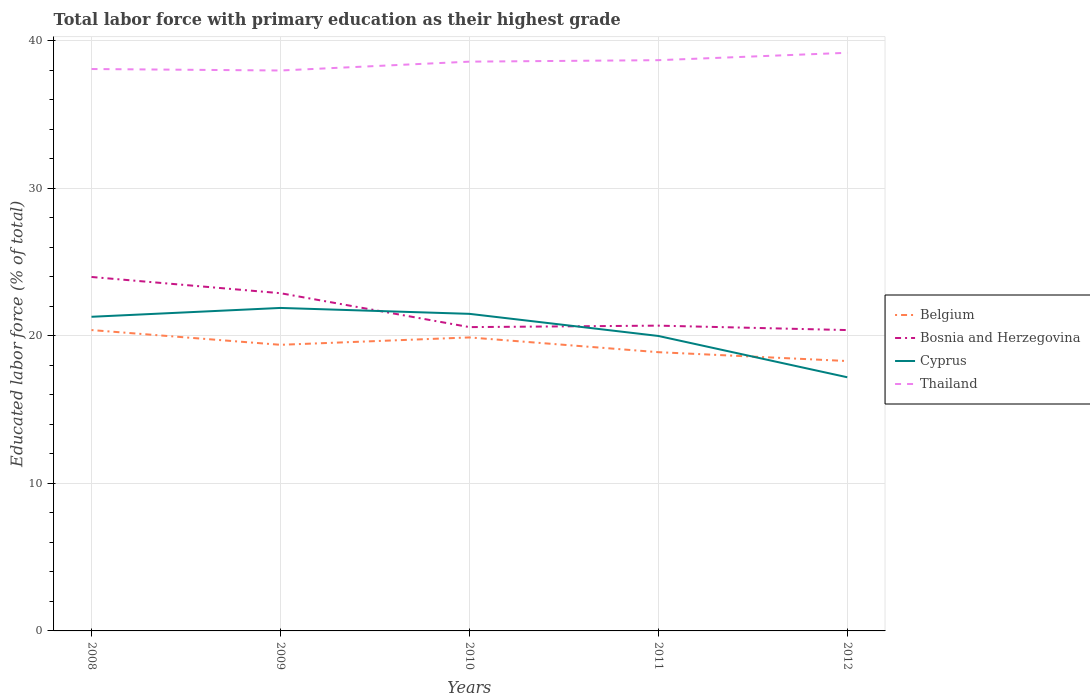Across all years, what is the maximum percentage of total labor force with primary education in Bosnia and Herzegovina?
Keep it short and to the point. 20.4. In which year was the percentage of total labor force with primary education in Thailand maximum?
Provide a succinct answer. 2009. What is the total percentage of total labor force with primary education in Bosnia and Herzegovina in the graph?
Make the answer very short. 1.1. What is the difference between the highest and the second highest percentage of total labor force with primary education in Belgium?
Provide a short and direct response. 2.1. Is the percentage of total labor force with primary education in Cyprus strictly greater than the percentage of total labor force with primary education in Belgium over the years?
Provide a succinct answer. No. How many lines are there?
Provide a succinct answer. 4. Does the graph contain grids?
Your answer should be compact. Yes. Where does the legend appear in the graph?
Provide a succinct answer. Center right. How many legend labels are there?
Your response must be concise. 4. How are the legend labels stacked?
Provide a short and direct response. Vertical. What is the title of the graph?
Offer a very short reply. Total labor force with primary education as their highest grade. What is the label or title of the Y-axis?
Your answer should be compact. Educated labor force (% of total). What is the Educated labor force (% of total) of Belgium in 2008?
Keep it short and to the point. 20.4. What is the Educated labor force (% of total) in Cyprus in 2008?
Keep it short and to the point. 21.3. What is the Educated labor force (% of total) of Thailand in 2008?
Your answer should be very brief. 38.1. What is the Educated labor force (% of total) of Belgium in 2009?
Your answer should be compact. 19.4. What is the Educated labor force (% of total) in Bosnia and Herzegovina in 2009?
Ensure brevity in your answer.  22.9. What is the Educated labor force (% of total) of Cyprus in 2009?
Ensure brevity in your answer.  21.9. What is the Educated labor force (% of total) of Belgium in 2010?
Ensure brevity in your answer.  19.9. What is the Educated labor force (% of total) in Bosnia and Herzegovina in 2010?
Make the answer very short. 20.6. What is the Educated labor force (% of total) in Cyprus in 2010?
Provide a short and direct response. 21.5. What is the Educated labor force (% of total) of Thailand in 2010?
Offer a very short reply. 38.6. What is the Educated labor force (% of total) of Belgium in 2011?
Offer a terse response. 18.9. What is the Educated labor force (% of total) in Bosnia and Herzegovina in 2011?
Ensure brevity in your answer.  20.7. What is the Educated labor force (% of total) of Thailand in 2011?
Offer a terse response. 38.7. What is the Educated labor force (% of total) of Belgium in 2012?
Offer a very short reply. 18.3. What is the Educated labor force (% of total) of Bosnia and Herzegovina in 2012?
Your answer should be compact. 20.4. What is the Educated labor force (% of total) of Cyprus in 2012?
Offer a very short reply. 17.2. What is the Educated labor force (% of total) of Thailand in 2012?
Your answer should be very brief. 39.2. Across all years, what is the maximum Educated labor force (% of total) of Belgium?
Offer a very short reply. 20.4. Across all years, what is the maximum Educated labor force (% of total) of Cyprus?
Keep it short and to the point. 21.9. Across all years, what is the maximum Educated labor force (% of total) in Thailand?
Provide a succinct answer. 39.2. Across all years, what is the minimum Educated labor force (% of total) of Belgium?
Offer a very short reply. 18.3. Across all years, what is the minimum Educated labor force (% of total) in Bosnia and Herzegovina?
Provide a succinct answer. 20.4. Across all years, what is the minimum Educated labor force (% of total) in Cyprus?
Give a very brief answer. 17.2. Across all years, what is the minimum Educated labor force (% of total) of Thailand?
Provide a short and direct response. 38. What is the total Educated labor force (% of total) in Belgium in the graph?
Provide a succinct answer. 96.9. What is the total Educated labor force (% of total) of Bosnia and Herzegovina in the graph?
Provide a succinct answer. 108.6. What is the total Educated labor force (% of total) in Cyprus in the graph?
Make the answer very short. 101.9. What is the total Educated labor force (% of total) in Thailand in the graph?
Keep it short and to the point. 192.6. What is the difference between the Educated labor force (% of total) in Belgium in 2008 and that in 2009?
Your answer should be compact. 1. What is the difference between the Educated labor force (% of total) of Cyprus in 2008 and that in 2009?
Your answer should be compact. -0.6. What is the difference between the Educated labor force (% of total) of Bosnia and Herzegovina in 2008 and that in 2011?
Provide a short and direct response. 3.3. What is the difference between the Educated labor force (% of total) in Cyprus in 2008 and that in 2011?
Offer a terse response. 1.3. What is the difference between the Educated labor force (% of total) in Thailand in 2008 and that in 2011?
Keep it short and to the point. -0.6. What is the difference between the Educated labor force (% of total) of Belgium in 2009 and that in 2010?
Ensure brevity in your answer.  -0.5. What is the difference between the Educated labor force (% of total) of Bosnia and Herzegovina in 2009 and that in 2010?
Make the answer very short. 2.3. What is the difference between the Educated labor force (% of total) of Thailand in 2009 and that in 2010?
Offer a very short reply. -0.6. What is the difference between the Educated labor force (% of total) of Belgium in 2009 and that in 2011?
Keep it short and to the point. 0.5. What is the difference between the Educated labor force (% of total) of Bosnia and Herzegovina in 2009 and that in 2011?
Offer a very short reply. 2.2. What is the difference between the Educated labor force (% of total) of Cyprus in 2009 and that in 2011?
Ensure brevity in your answer.  1.9. What is the difference between the Educated labor force (% of total) in Thailand in 2009 and that in 2011?
Provide a short and direct response. -0.7. What is the difference between the Educated labor force (% of total) in Belgium in 2009 and that in 2012?
Give a very brief answer. 1.1. What is the difference between the Educated labor force (% of total) in Belgium in 2010 and that in 2011?
Your answer should be very brief. 1. What is the difference between the Educated labor force (% of total) of Thailand in 2010 and that in 2011?
Offer a terse response. -0.1. What is the difference between the Educated labor force (% of total) of Belgium in 2010 and that in 2012?
Provide a short and direct response. 1.6. What is the difference between the Educated labor force (% of total) in Cyprus in 2010 and that in 2012?
Provide a short and direct response. 4.3. What is the difference between the Educated labor force (% of total) of Thailand in 2010 and that in 2012?
Give a very brief answer. -0.6. What is the difference between the Educated labor force (% of total) of Bosnia and Herzegovina in 2011 and that in 2012?
Offer a terse response. 0.3. What is the difference between the Educated labor force (% of total) of Cyprus in 2011 and that in 2012?
Your answer should be very brief. 2.8. What is the difference between the Educated labor force (% of total) in Belgium in 2008 and the Educated labor force (% of total) in Cyprus in 2009?
Offer a terse response. -1.5. What is the difference between the Educated labor force (% of total) in Belgium in 2008 and the Educated labor force (% of total) in Thailand in 2009?
Your answer should be very brief. -17.6. What is the difference between the Educated labor force (% of total) in Bosnia and Herzegovina in 2008 and the Educated labor force (% of total) in Cyprus in 2009?
Provide a succinct answer. 2.1. What is the difference between the Educated labor force (% of total) in Bosnia and Herzegovina in 2008 and the Educated labor force (% of total) in Thailand in 2009?
Make the answer very short. -14. What is the difference between the Educated labor force (% of total) of Cyprus in 2008 and the Educated labor force (% of total) of Thailand in 2009?
Your answer should be compact. -16.7. What is the difference between the Educated labor force (% of total) of Belgium in 2008 and the Educated labor force (% of total) of Bosnia and Herzegovina in 2010?
Your response must be concise. -0.2. What is the difference between the Educated labor force (% of total) of Belgium in 2008 and the Educated labor force (% of total) of Thailand in 2010?
Your answer should be compact. -18.2. What is the difference between the Educated labor force (% of total) of Bosnia and Herzegovina in 2008 and the Educated labor force (% of total) of Thailand in 2010?
Provide a succinct answer. -14.6. What is the difference between the Educated labor force (% of total) of Cyprus in 2008 and the Educated labor force (% of total) of Thailand in 2010?
Offer a terse response. -17.3. What is the difference between the Educated labor force (% of total) of Belgium in 2008 and the Educated labor force (% of total) of Bosnia and Herzegovina in 2011?
Offer a terse response. -0.3. What is the difference between the Educated labor force (% of total) in Belgium in 2008 and the Educated labor force (% of total) in Thailand in 2011?
Offer a terse response. -18.3. What is the difference between the Educated labor force (% of total) in Bosnia and Herzegovina in 2008 and the Educated labor force (% of total) in Cyprus in 2011?
Give a very brief answer. 4. What is the difference between the Educated labor force (% of total) of Bosnia and Herzegovina in 2008 and the Educated labor force (% of total) of Thailand in 2011?
Give a very brief answer. -14.7. What is the difference between the Educated labor force (% of total) in Cyprus in 2008 and the Educated labor force (% of total) in Thailand in 2011?
Give a very brief answer. -17.4. What is the difference between the Educated labor force (% of total) in Belgium in 2008 and the Educated labor force (% of total) in Bosnia and Herzegovina in 2012?
Offer a very short reply. 0. What is the difference between the Educated labor force (% of total) in Belgium in 2008 and the Educated labor force (% of total) in Thailand in 2012?
Your answer should be very brief. -18.8. What is the difference between the Educated labor force (% of total) in Bosnia and Herzegovina in 2008 and the Educated labor force (% of total) in Cyprus in 2012?
Keep it short and to the point. 6.8. What is the difference between the Educated labor force (% of total) in Bosnia and Herzegovina in 2008 and the Educated labor force (% of total) in Thailand in 2012?
Give a very brief answer. -15.2. What is the difference between the Educated labor force (% of total) of Cyprus in 2008 and the Educated labor force (% of total) of Thailand in 2012?
Offer a terse response. -17.9. What is the difference between the Educated labor force (% of total) in Belgium in 2009 and the Educated labor force (% of total) in Cyprus in 2010?
Your response must be concise. -2.1. What is the difference between the Educated labor force (% of total) in Belgium in 2009 and the Educated labor force (% of total) in Thailand in 2010?
Provide a succinct answer. -19.2. What is the difference between the Educated labor force (% of total) in Bosnia and Herzegovina in 2009 and the Educated labor force (% of total) in Cyprus in 2010?
Give a very brief answer. 1.4. What is the difference between the Educated labor force (% of total) of Bosnia and Herzegovina in 2009 and the Educated labor force (% of total) of Thailand in 2010?
Offer a very short reply. -15.7. What is the difference between the Educated labor force (% of total) of Cyprus in 2009 and the Educated labor force (% of total) of Thailand in 2010?
Provide a short and direct response. -16.7. What is the difference between the Educated labor force (% of total) of Belgium in 2009 and the Educated labor force (% of total) of Cyprus in 2011?
Offer a terse response. -0.6. What is the difference between the Educated labor force (% of total) of Belgium in 2009 and the Educated labor force (% of total) of Thailand in 2011?
Make the answer very short. -19.3. What is the difference between the Educated labor force (% of total) of Bosnia and Herzegovina in 2009 and the Educated labor force (% of total) of Thailand in 2011?
Give a very brief answer. -15.8. What is the difference between the Educated labor force (% of total) in Cyprus in 2009 and the Educated labor force (% of total) in Thailand in 2011?
Keep it short and to the point. -16.8. What is the difference between the Educated labor force (% of total) of Belgium in 2009 and the Educated labor force (% of total) of Bosnia and Herzegovina in 2012?
Give a very brief answer. -1. What is the difference between the Educated labor force (% of total) of Belgium in 2009 and the Educated labor force (% of total) of Cyprus in 2012?
Your answer should be very brief. 2.2. What is the difference between the Educated labor force (% of total) of Belgium in 2009 and the Educated labor force (% of total) of Thailand in 2012?
Your answer should be compact. -19.8. What is the difference between the Educated labor force (% of total) in Bosnia and Herzegovina in 2009 and the Educated labor force (% of total) in Thailand in 2012?
Keep it short and to the point. -16.3. What is the difference between the Educated labor force (% of total) of Cyprus in 2009 and the Educated labor force (% of total) of Thailand in 2012?
Offer a terse response. -17.3. What is the difference between the Educated labor force (% of total) of Belgium in 2010 and the Educated labor force (% of total) of Thailand in 2011?
Make the answer very short. -18.8. What is the difference between the Educated labor force (% of total) in Bosnia and Herzegovina in 2010 and the Educated labor force (% of total) in Cyprus in 2011?
Provide a short and direct response. 0.6. What is the difference between the Educated labor force (% of total) in Bosnia and Herzegovina in 2010 and the Educated labor force (% of total) in Thailand in 2011?
Offer a very short reply. -18.1. What is the difference between the Educated labor force (% of total) of Cyprus in 2010 and the Educated labor force (% of total) of Thailand in 2011?
Your answer should be compact. -17.2. What is the difference between the Educated labor force (% of total) in Belgium in 2010 and the Educated labor force (% of total) in Cyprus in 2012?
Provide a short and direct response. 2.7. What is the difference between the Educated labor force (% of total) of Belgium in 2010 and the Educated labor force (% of total) of Thailand in 2012?
Keep it short and to the point. -19.3. What is the difference between the Educated labor force (% of total) in Bosnia and Herzegovina in 2010 and the Educated labor force (% of total) in Thailand in 2012?
Your response must be concise. -18.6. What is the difference between the Educated labor force (% of total) in Cyprus in 2010 and the Educated labor force (% of total) in Thailand in 2012?
Your response must be concise. -17.7. What is the difference between the Educated labor force (% of total) of Belgium in 2011 and the Educated labor force (% of total) of Thailand in 2012?
Provide a succinct answer. -20.3. What is the difference between the Educated labor force (% of total) of Bosnia and Herzegovina in 2011 and the Educated labor force (% of total) of Cyprus in 2012?
Provide a short and direct response. 3.5. What is the difference between the Educated labor force (% of total) in Bosnia and Herzegovina in 2011 and the Educated labor force (% of total) in Thailand in 2012?
Ensure brevity in your answer.  -18.5. What is the difference between the Educated labor force (% of total) of Cyprus in 2011 and the Educated labor force (% of total) of Thailand in 2012?
Your answer should be compact. -19.2. What is the average Educated labor force (% of total) of Belgium per year?
Provide a short and direct response. 19.38. What is the average Educated labor force (% of total) of Bosnia and Herzegovina per year?
Your answer should be very brief. 21.72. What is the average Educated labor force (% of total) in Cyprus per year?
Ensure brevity in your answer.  20.38. What is the average Educated labor force (% of total) of Thailand per year?
Make the answer very short. 38.52. In the year 2008, what is the difference between the Educated labor force (% of total) of Belgium and Educated labor force (% of total) of Bosnia and Herzegovina?
Offer a terse response. -3.6. In the year 2008, what is the difference between the Educated labor force (% of total) of Belgium and Educated labor force (% of total) of Cyprus?
Provide a succinct answer. -0.9. In the year 2008, what is the difference between the Educated labor force (% of total) of Belgium and Educated labor force (% of total) of Thailand?
Offer a very short reply. -17.7. In the year 2008, what is the difference between the Educated labor force (% of total) of Bosnia and Herzegovina and Educated labor force (% of total) of Cyprus?
Your answer should be compact. 2.7. In the year 2008, what is the difference between the Educated labor force (% of total) of Bosnia and Herzegovina and Educated labor force (% of total) of Thailand?
Your answer should be very brief. -14.1. In the year 2008, what is the difference between the Educated labor force (% of total) of Cyprus and Educated labor force (% of total) of Thailand?
Provide a short and direct response. -16.8. In the year 2009, what is the difference between the Educated labor force (% of total) in Belgium and Educated labor force (% of total) in Bosnia and Herzegovina?
Offer a very short reply. -3.5. In the year 2009, what is the difference between the Educated labor force (% of total) in Belgium and Educated labor force (% of total) in Cyprus?
Make the answer very short. -2.5. In the year 2009, what is the difference between the Educated labor force (% of total) in Belgium and Educated labor force (% of total) in Thailand?
Provide a short and direct response. -18.6. In the year 2009, what is the difference between the Educated labor force (% of total) in Bosnia and Herzegovina and Educated labor force (% of total) in Thailand?
Give a very brief answer. -15.1. In the year 2009, what is the difference between the Educated labor force (% of total) in Cyprus and Educated labor force (% of total) in Thailand?
Your answer should be compact. -16.1. In the year 2010, what is the difference between the Educated labor force (% of total) of Belgium and Educated labor force (% of total) of Thailand?
Your answer should be compact. -18.7. In the year 2010, what is the difference between the Educated labor force (% of total) of Cyprus and Educated labor force (% of total) of Thailand?
Make the answer very short. -17.1. In the year 2011, what is the difference between the Educated labor force (% of total) of Belgium and Educated labor force (% of total) of Thailand?
Your response must be concise. -19.8. In the year 2011, what is the difference between the Educated labor force (% of total) in Cyprus and Educated labor force (% of total) in Thailand?
Keep it short and to the point. -18.7. In the year 2012, what is the difference between the Educated labor force (% of total) of Belgium and Educated labor force (% of total) of Thailand?
Offer a very short reply. -20.9. In the year 2012, what is the difference between the Educated labor force (% of total) in Bosnia and Herzegovina and Educated labor force (% of total) in Thailand?
Give a very brief answer. -18.8. In the year 2012, what is the difference between the Educated labor force (% of total) in Cyprus and Educated labor force (% of total) in Thailand?
Ensure brevity in your answer.  -22. What is the ratio of the Educated labor force (% of total) in Belgium in 2008 to that in 2009?
Provide a succinct answer. 1.05. What is the ratio of the Educated labor force (% of total) of Bosnia and Herzegovina in 2008 to that in 2009?
Give a very brief answer. 1.05. What is the ratio of the Educated labor force (% of total) in Cyprus in 2008 to that in 2009?
Give a very brief answer. 0.97. What is the ratio of the Educated labor force (% of total) in Thailand in 2008 to that in 2009?
Provide a short and direct response. 1. What is the ratio of the Educated labor force (% of total) of Belgium in 2008 to that in 2010?
Your response must be concise. 1.03. What is the ratio of the Educated labor force (% of total) of Bosnia and Herzegovina in 2008 to that in 2010?
Offer a terse response. 1.17. What is the ratio of the Educated labor force (% of total) in Belgium in 2008 to that in 2011?
Offer a very short reply. 1.08. What is the ratio of the Educated labor force (% of total) of Bosnia and Herzegovina in 2008 to that in 2011?
Keep it short and to the point. 1.16. What is the ratio of the Educated labor force (% of total) in Cyprus in 2008 to that in 2011?
Give a very brief answer. 1.06. What is the ratio of the Educated labor force (% of total) of Thailand in 2008 to that in 2011?
Keep it short and to the point. 0.98. What is the ratio of the Educated labor force (% of total) in Belgium in 2008 to that in 2012?
Your response must be concise. 1.11. What is the ratio of the Educated labor force (% of total) of Bosnia and Herzegovina in 2008 to that in 2012?
Your answer should be very brief. 1.18. What is the ratio of the Educated labor force (% of total) of Cyprus in 2008 to that in 2012?
Offer a very short reply. 1.24. What is the ratio of the Educated labor force (% of total) in Thailand in 2008 to that in 2012?
Ensure brevity in your answer.  0.97. What is the ratio of the Educated labor force (% of total) in Belgium in 2009 to that in 2010?
Give a very brief answer. 0.97. What is the ratio of the Educated labor force (% of total) in Bosnia and Herzegovina in 2009 to that in 2010?
Your answer should be very brief. 1.11. What is the ratio of the Educated labor force (% of total) in Cyprus in 2009 to that in 2010?
Make the answer very short. 1.02. What is the ratio of the Educated labor force (% of total) of Thailand in 2009 to that in 2010?
Ensure brevity in your answer.  0.98. What is the ratio of the Educated labor force (% of total) of Belgium in 2009 to that in 2011?
Make the answer very short. 1.03. What is the ratio of the Educated labor force (% of total) in Bosnia and Herzegovina in 2009 to that in 2011?
Keep it short and to the point. 1.11. What is the ratio of the Educated labor force (% of total) in Cyprus in 2009 to that in 2011?
Keep it short and to the point. 1.09. What is the ratio of the Educated labor force (% of total) of Thailand in 2009 to that in 2011?
Ensure brevity in your answer.  0.98. What is the ratio of the Educated labor force (% of total) of Belgium in 2009 to that in 2012?
Your response must be concise. 1.06. What is the ratio of the Educated labor force (% of total) of Bosnia and Herzegovina in 2009 to that in 2012?
Ensure brevity in your answer.  1.12. What is the ratio of the Educated labor force (% of total) of Cyprus in 2009 to that in 2012?
Your response must be concise. 1.27. What is the ratio of the Educated labor force (% of total) in Thailand in 2009 to that in 2012?
Make the answer very short. 0.97. What is the ratio of the Educated labor force (% of total) of Belgium in 2010 to that in 2011?
Your answer should be very brief. 1.05. What is the ratio of the Educated labor force (% of total) of Cyprus in 2010 to that in 2011?
Your response must be concise. 1.07. What is the ratio of the Educated labor force (% of total) of Belgium in 2010 to that in 2012?
Your answer should be very brief. 1.09. What is the ratio of the Educated labor force (% of total) of Bosnia and Herzegovina in 2010 to that in 2012?
Your answer should be very brief. 1.01. What is the ratio of the Educated labor force (% of total) in Cyprus in 2010 to that in 2012?
Make the answer very short. 1.25. What is the ratio of the Educated labor force (% of total) in Thailand in 2010 to that in 2012?
Keep it short and to the point. 0.98. What is the ratio of the Educated labor force (% of total) in Belgium in 2011 to that in 2012?
Provide a short and direct response. 1.03. What is the ratio of the Educated labor force (% of total) of Bosnia and Herzegovina in 2011 to that in 2012?
Ensure brevity in your answer.  1.01. What is the ratio of the Educated labor force (% of total) of Cyprus in 2011 to that in 2012?
Keep it short and to the point. 1.16. What is the ratio of the Educated labor force (% of total) in Thailand in 2011 to that in 2012?
Provide a succinct answer. 0.99. What is the difference between the highest and the second highest Educated labor force (% of total) of Belgium?
Provide a succinct answer. 0.5. What is the difference between the highest and the lowest Educated labor force (% of total) in Bosnia and Herzegovina?
Your answer should be compact. 3.6. What is the difference between the highest and the lowest Educated labor force (% of total) of Cyprus?
Offer a terse response. 4.7. What is the difference between the highest and the lowest Educated labor force (% of total) of Thailand?
Make the answer very short. 1.2. 